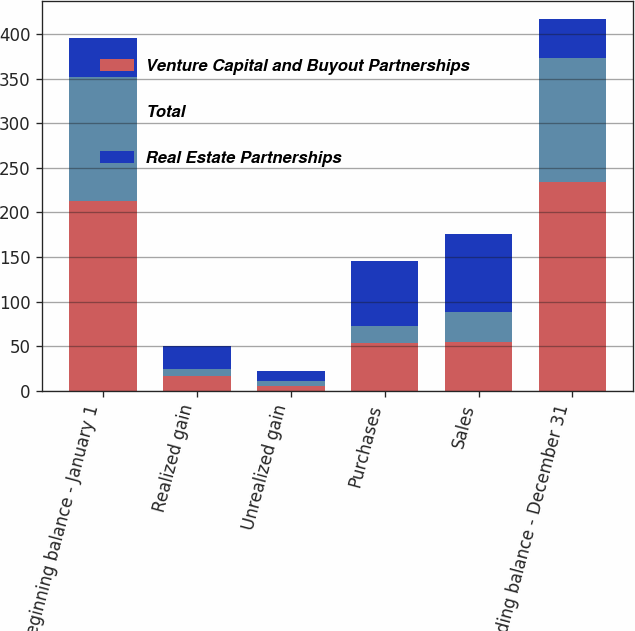Convert chart to OTSL. <chart><loc_0><loc_0><loc_500><loc_500><stacked_bar_chart><ecel><fcel>Beginning balance - January 1<fcel>Realized gain<fcel>Unrealized gain<fcel>Purchases<fcel>Sales<fcel>Ending balance - December 31<nl><fcel>Venture Capital and Buyout Partnerships<fcel>213<fcel>17<fcel>5<fcel>54<fcel>55<fcel>234<nl><fcel>Total<fcel>139<fcel>8<fcel>6<fcel>19<fcel>33<fcel>139<nl><fcel>Real Estate Partnerships<fcel>43.5<fcel>25<fcel>11<fcel>73<fcel>88<fcel>43.5<nl></chart> 